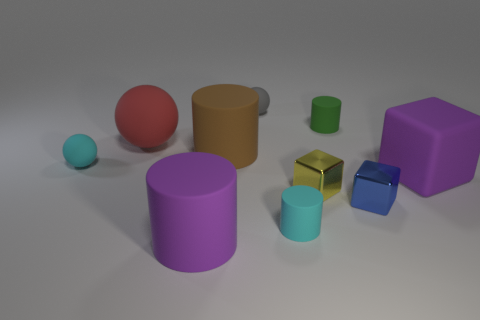Subtract all cubes. How many objects are left? 7 Add 6 tiny green objects. How many tiny green objects exist? 7 Subtract 0 green blocks. How many objects are left? 10 Subtract all red things. Subtract all small green matte cylinders. How many objects are left? 8 Add 3 green rubber objects. How many green rubber objects are left? 4 